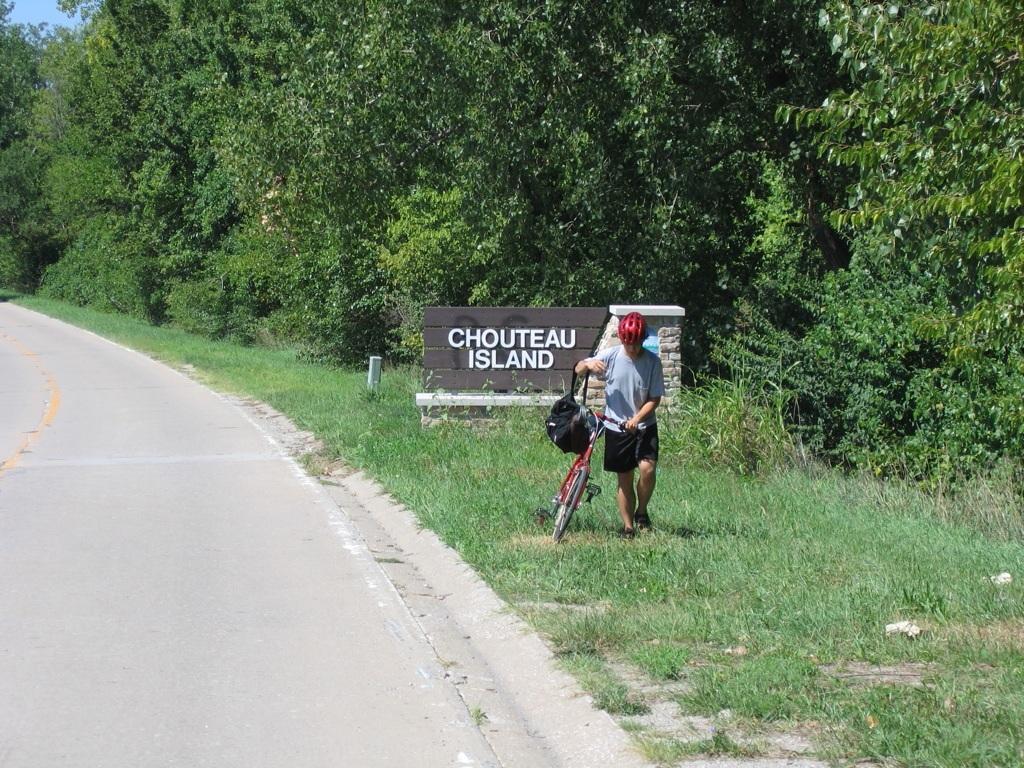Could you give a brief overview of what you see in this image? This image consists of a person walking along with a cycle. In the background, we can see a wall on which there is a text. On the left, there is a road. In the background, there are many trees. At the bottom, there is green grass. 